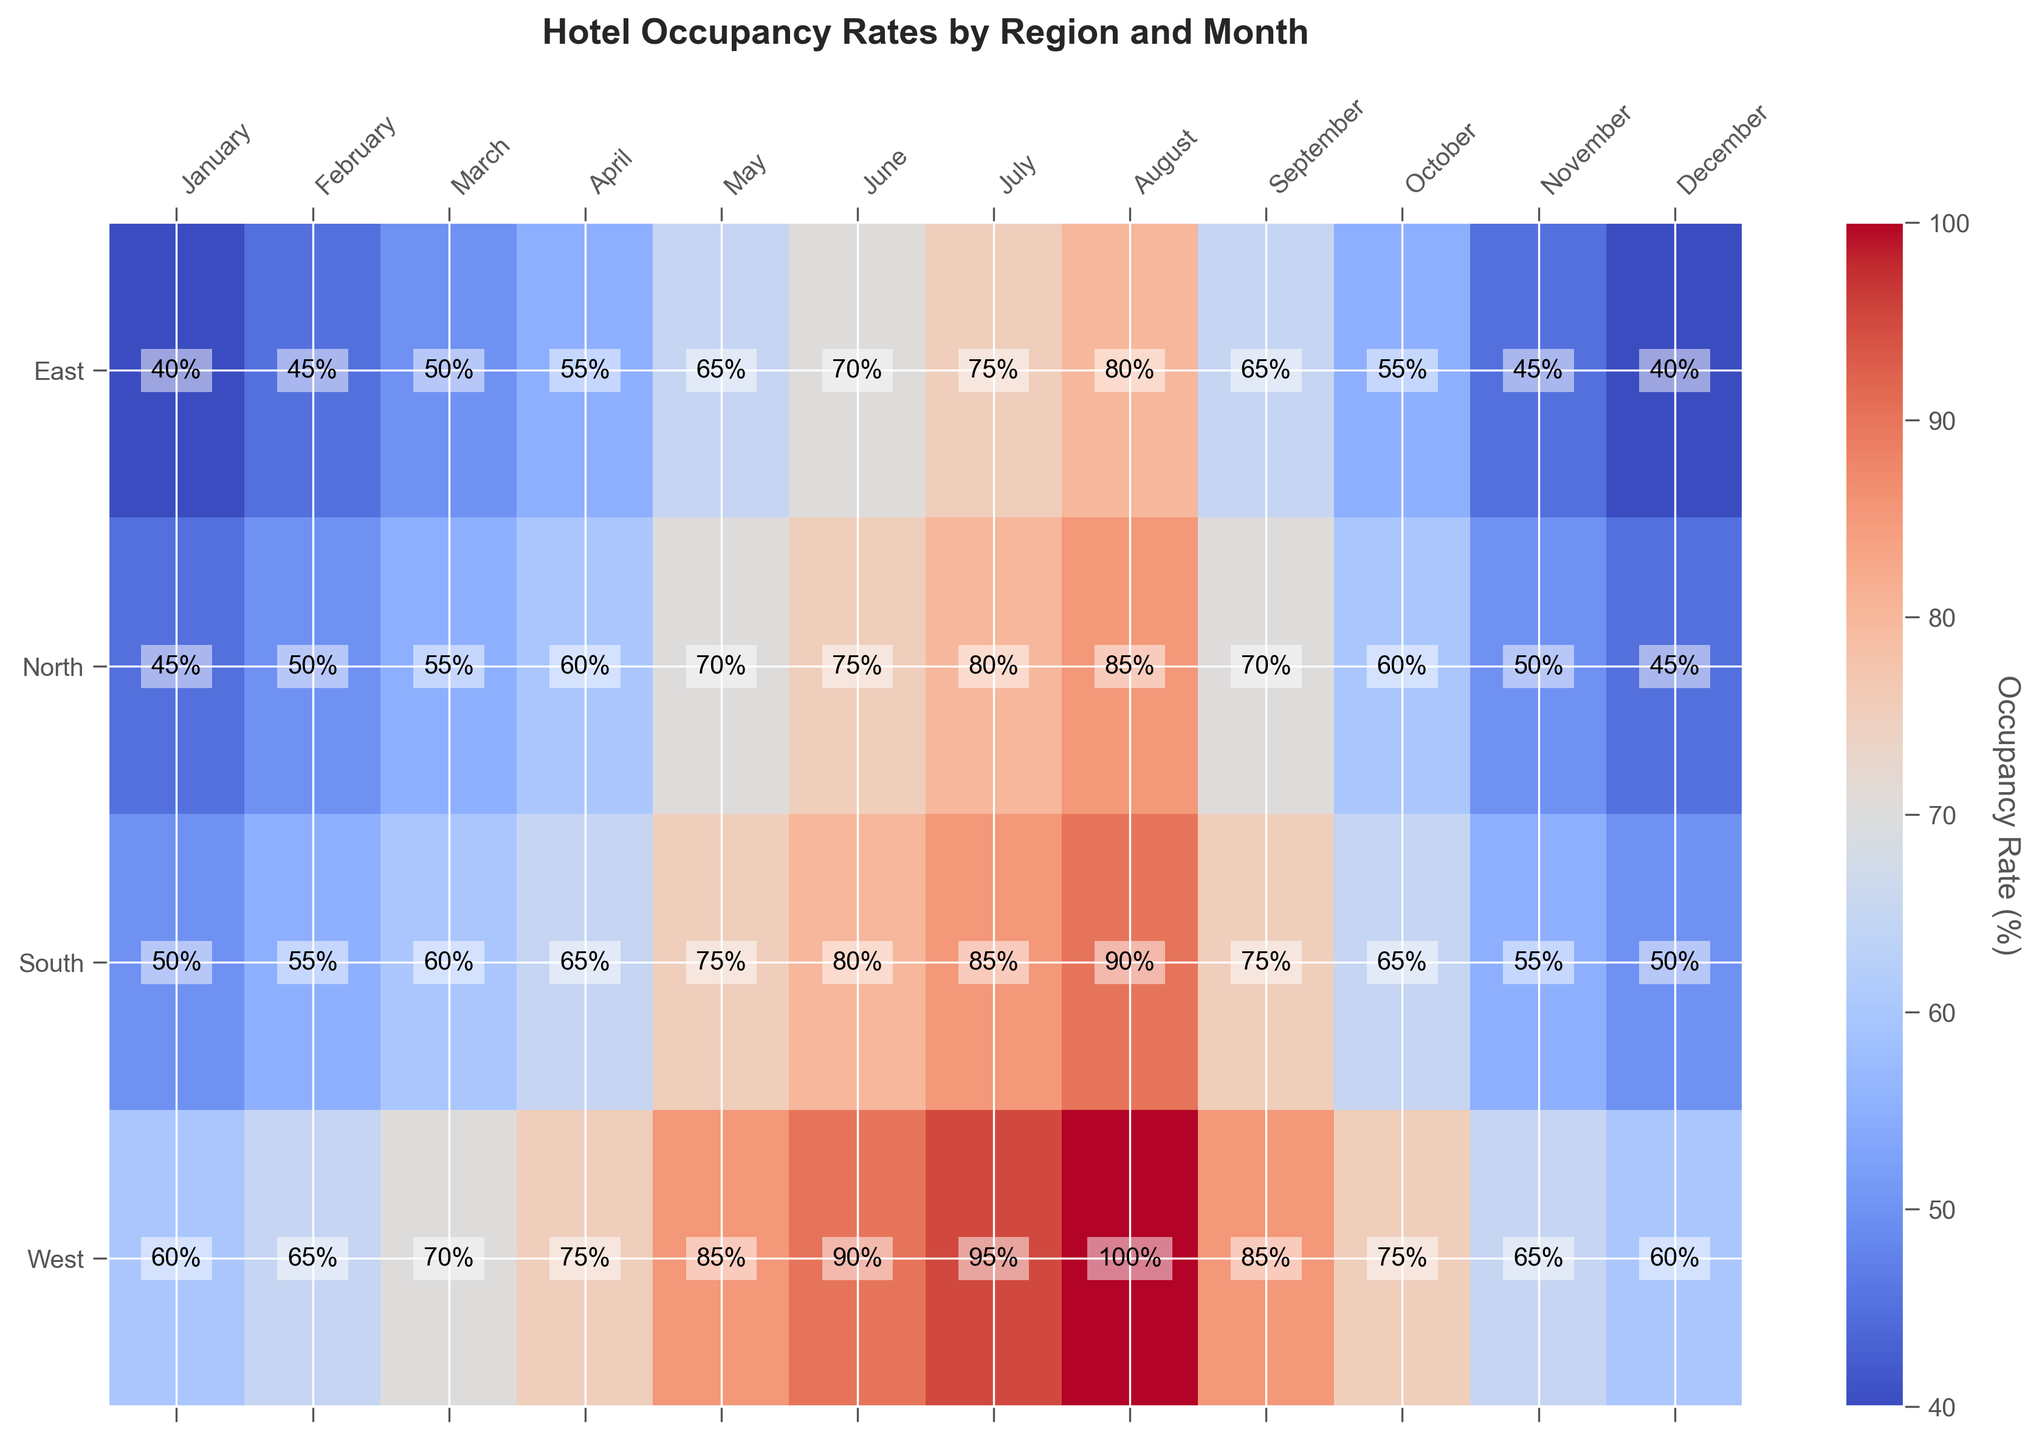Which region has the highest occupancy rate in August? By looking at the figure, we can observe the color intensity for the month of August. The 'West' region shows a significantly intense color corresponding to a high occupancy rate of 100%, whereas other regions display lower rates.
Answer: West Which month has the lowest occupancy rate for the East region? By examining the colors and values for the East region row, January and December show both an occupancy rate of 40%, which is the lowest value for this region.
Answer: January, December How does the occupancy rate in July for the North region compare to the same month for the South region? For July, the North region has an occupancy rate of 80%, while the South region has an occupancy rate of 85%. Hence, the occupancy rate is slightly higher for the South region.
Answer: South is higher Which months have an occupancy rate above 90% in the West region? By inspecting the occupancy rates for the West region across all months, both July and August have occupancy rates above 90%. Specifically, July is 95% and August is 100%.
Answer: July, August What is the average occupancy rate across all regions for May? The occupancy rates for May are North: 70%, South: 75%, East: 65%, and West: 85%. The average occupancy rate is calculated as (70 + 75 + 65 + 85) / 4 = 73.75%.
Answer: 73.75% Is there any month where all regions have the same occupancy rate? By visually comparing each month across the different regions, we observe that there is no month where all regions have the same occupancy rate.
Answer: No In which season (January to March) does the South region show the most significant increase in occupancy rate? By checking the values for January to March in the South region, we see rates of 50% in January, 55% in February, and 60% in March. The increase per month is 5%. The most significant increase within these months is observed from February to March.
Answer: February to March What is the sum of occupancy rates for the North region during autumn (September to November)? Autumn months are September, October, and November. The occupancy rates for these months in the North region are 70%, 60%, and 50%, respectively. Adding these values gives 70 + 60 + 50 = 180%.
Answer: 180% Which month shows the highest occupancy rate for the North region, and what's the value? By scanning through the column for the North region, August displays the highest occupancy rate at 85%.
Answer: August, 85% How much higher is the occupancy rate in August for the South region compared to the January rate in the same region? The occupancy rate for the South region in August is 90%, whereas in January, it is 50%. The difference is 90% - 50% = 40%.
Answer: 40% 